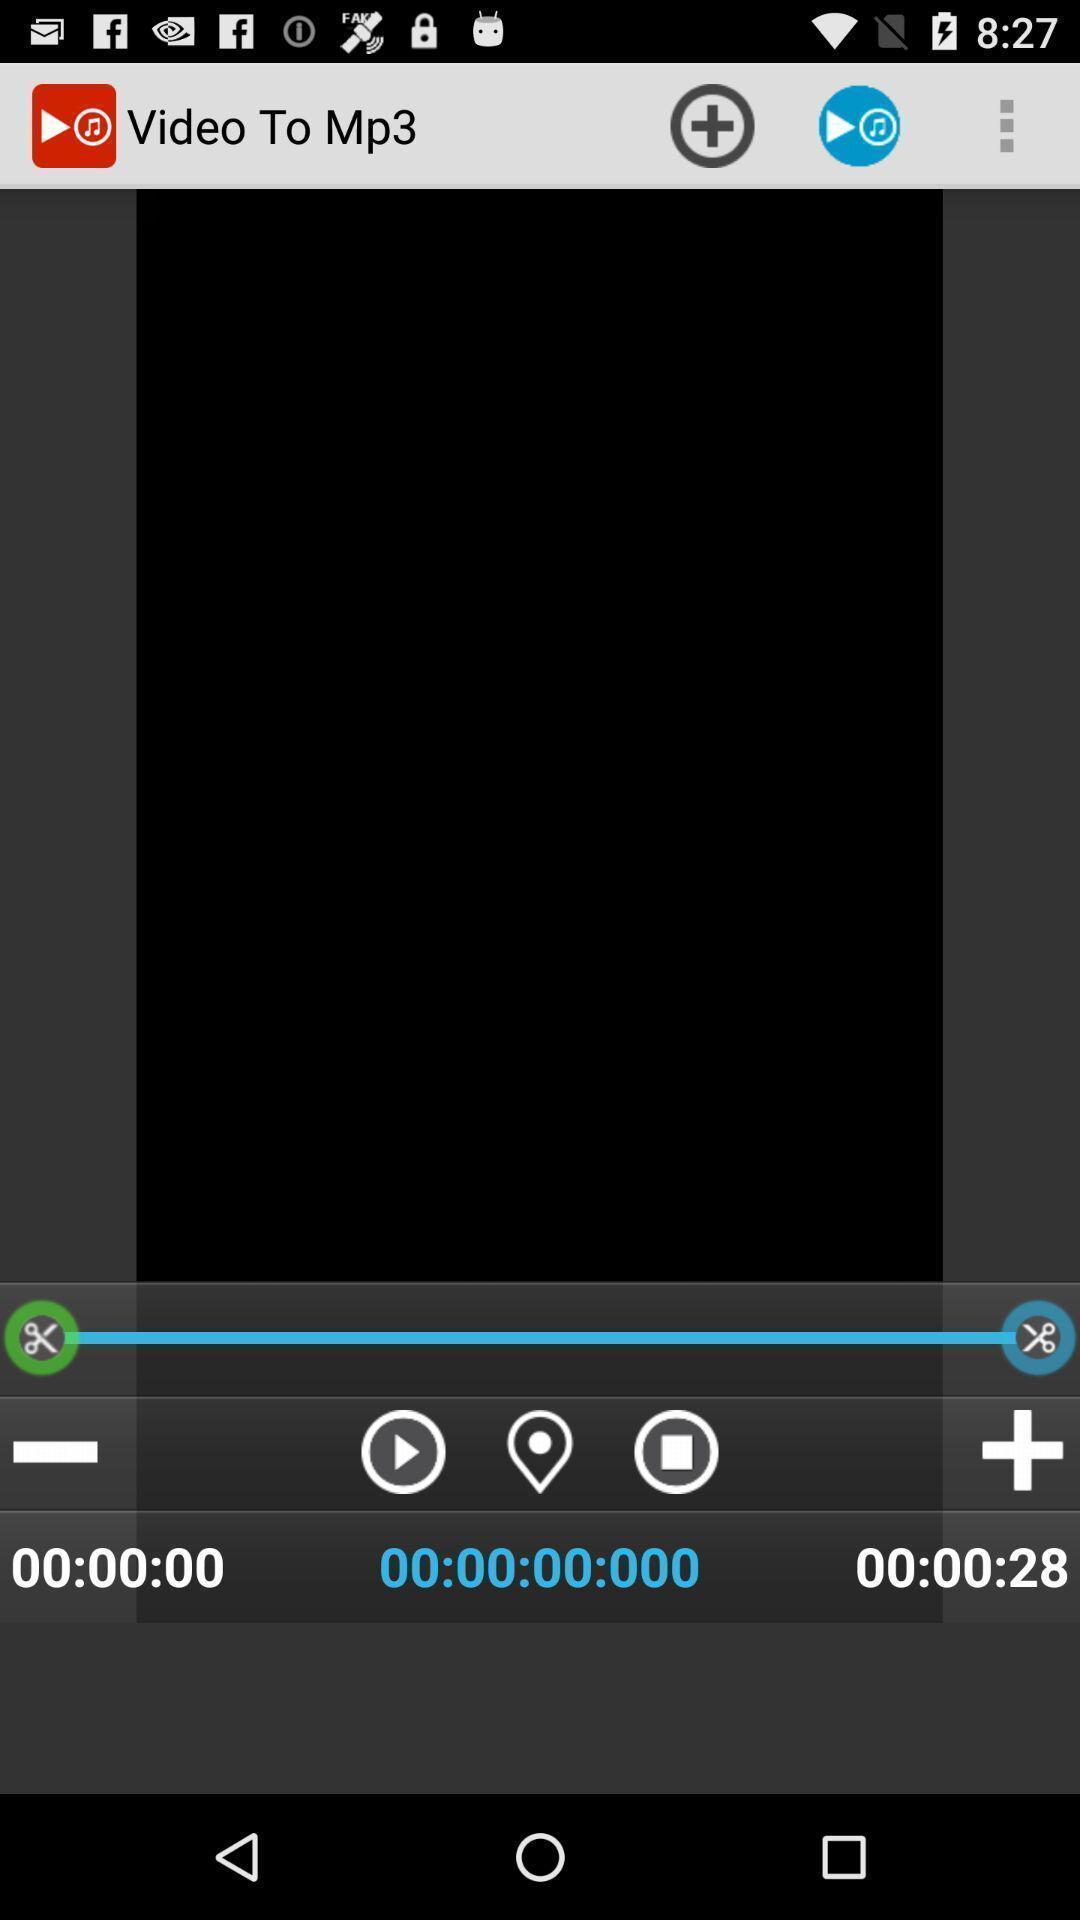Give me a narrative description of this picture. Page showing the video bar with multiple options. 